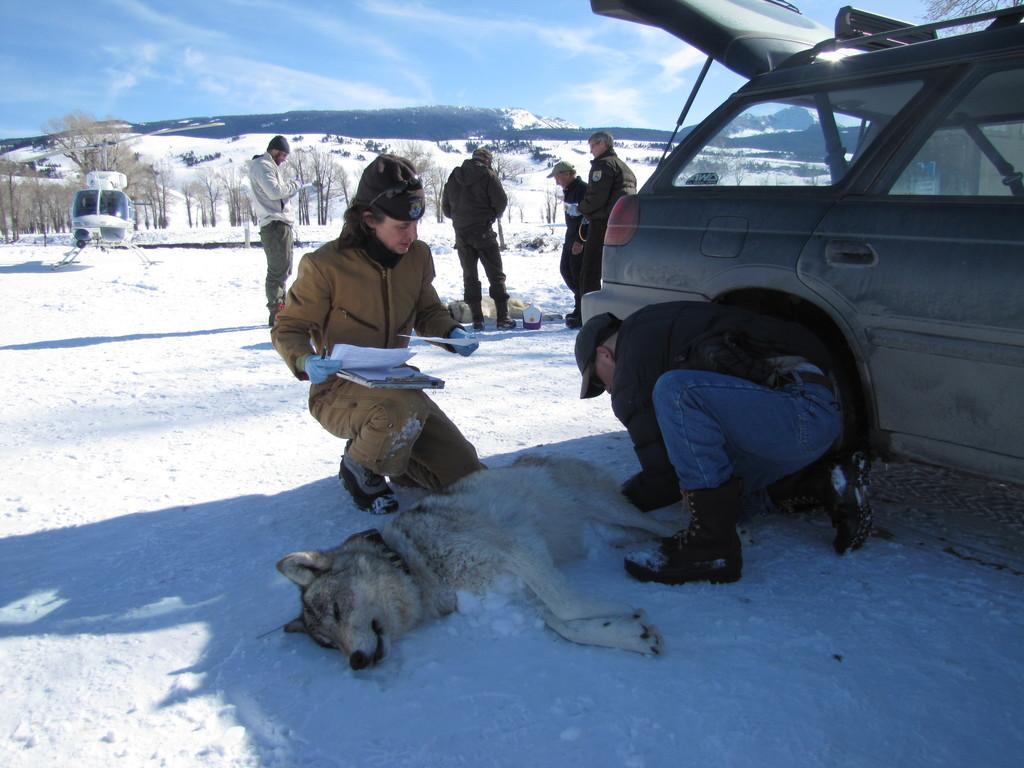What is the primary setting of the image? The primary setting of the image is a sky. What type of natural elements can be seen in the image? There are trees and snow visible in the image. Are there any human figures present in the image? Yes, there are people in the image. What type of vehicle can be seen in the image? There is a car in the image. What kind of animal is present in the image? There is a dog in the image. What type of action is the doctor performing on the patient in the image? There is no doctor or patient present in the image; it features a sky, trees, snow, people, a car, and a dog. 